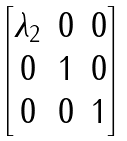Convert formula to latex. <formula><loc_0><loc_0><loc_500><loc_500>\begin{bmatrix} \lambda _ { 2 } & 0 & 0 \\ 0 & 1 & 0 \\ 0 & 0 & 1 \\ \end{bmatrix}</formula> 